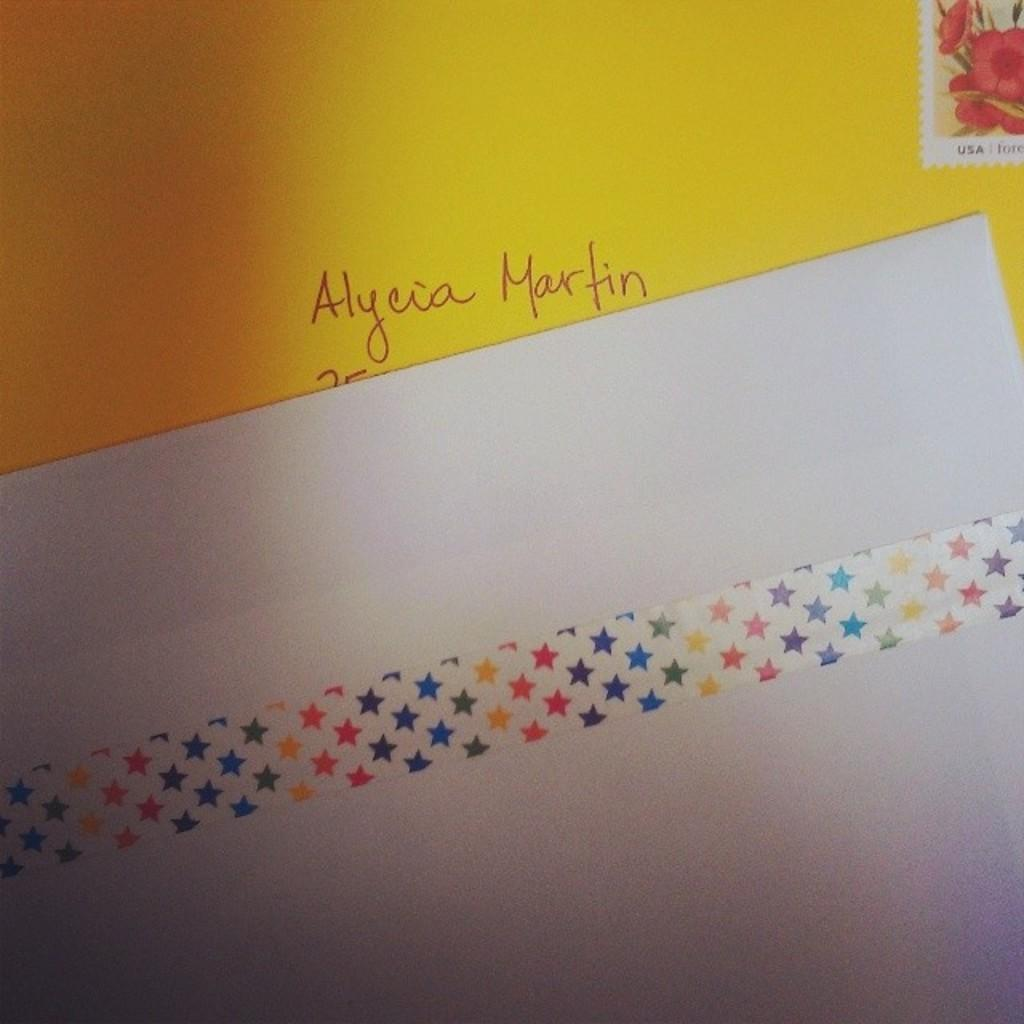<image>
Describe the image concisely. Envelope with the name Alycia Martin wrote on the front with a stamp 